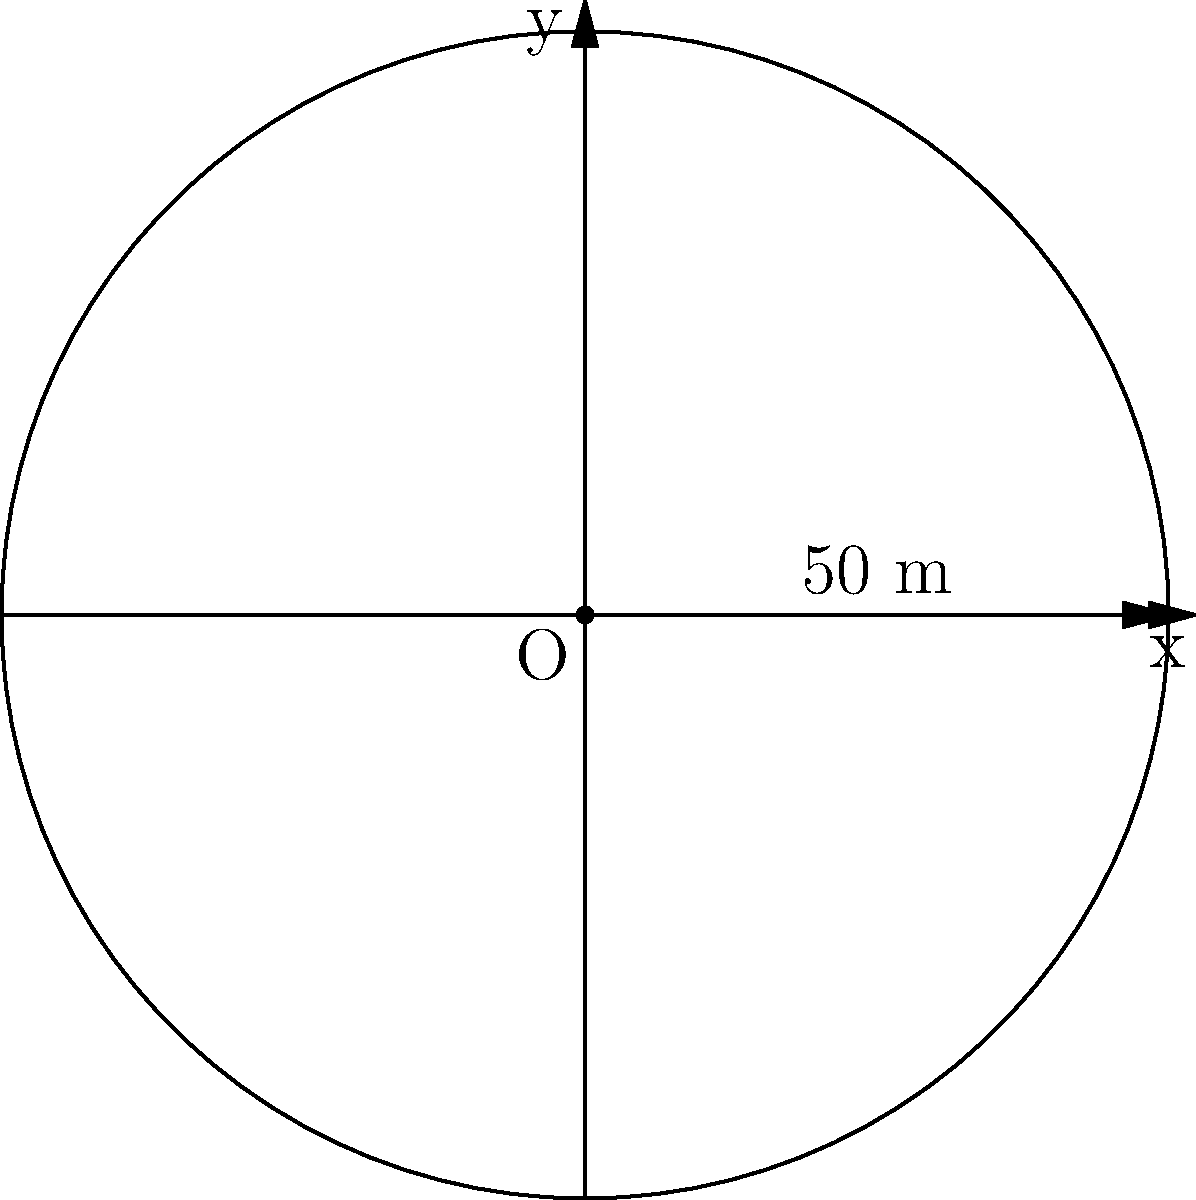You're planning a circular logging site. The boundary of the site can be described in polar coordinates by the equation $r = 50$ (where $r$ is in meters). Calculate the total area of the logging site in square meters. To find the area of the circular logging site, we'll follow these steps:

1) The general formula for the area of a region in polar coordinates is:

   $$A = \frac{1}{2} \int_{0}^{2\pi} r^2(\theta) d\theta$$

2) In this case, $r(\theta) = 50$ (constant), so we can simplify:

   $$A = \frac{1}{2} \int_{0}^{2\pi} 50^2 d\theta$$

3) Factor out the constant:

   $$A = \frac{1}{2} \cdot 50^2 \int_{0}^{2\pi} d\theta$$

4) Evaluate the integral:

   $$A = \frac{1}{2} \cdot 50^2 \cdot [2\pi - 0]$$

5) Simplify:

   $$A = \frac{1}{2} \cdot 2500 \cdot 2\pi = 2500\pi$$

Therefore, the area of the logging site is $2500\pi$ square meters.
Answer: $2500\pi$ m² 